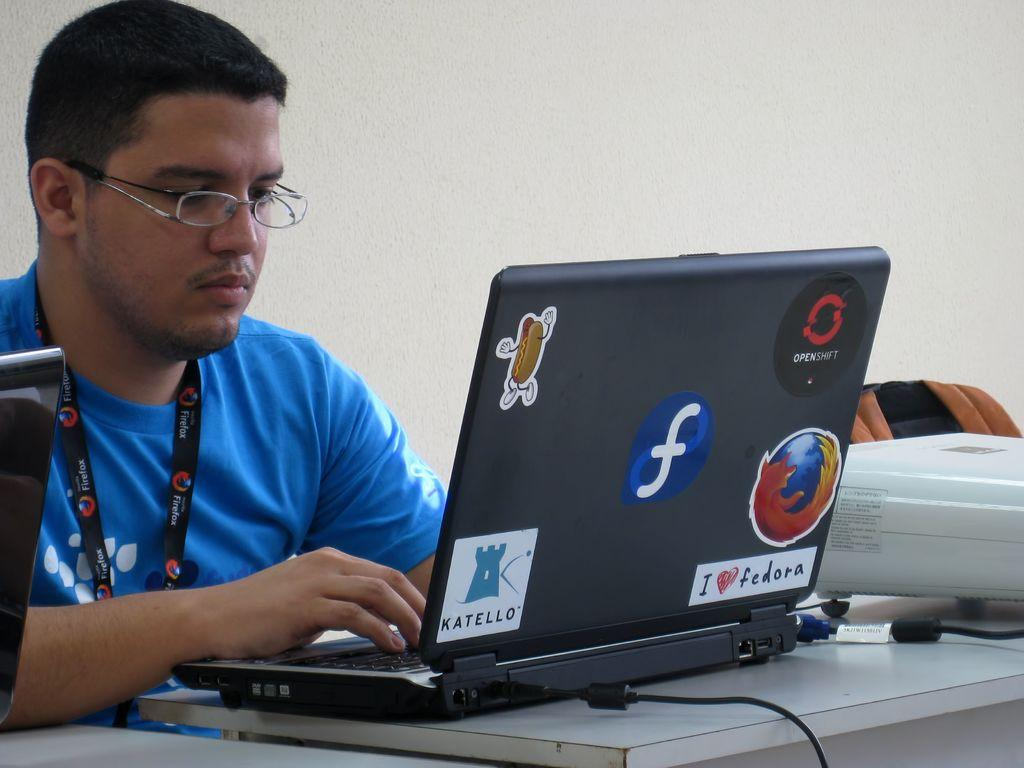<image>
Relay a brief, clear account of the picture shown. A man sits at a laptop which has the word Katello on its back. 